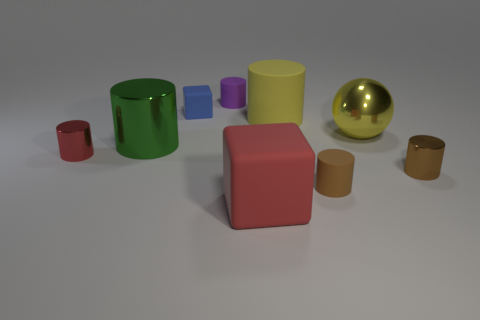Which objects have colors that might be considered warm colors? The objects in the image that have warm colors are the red small cylinder on the left, the gold sphere, and the tan small cuboid on the right. 